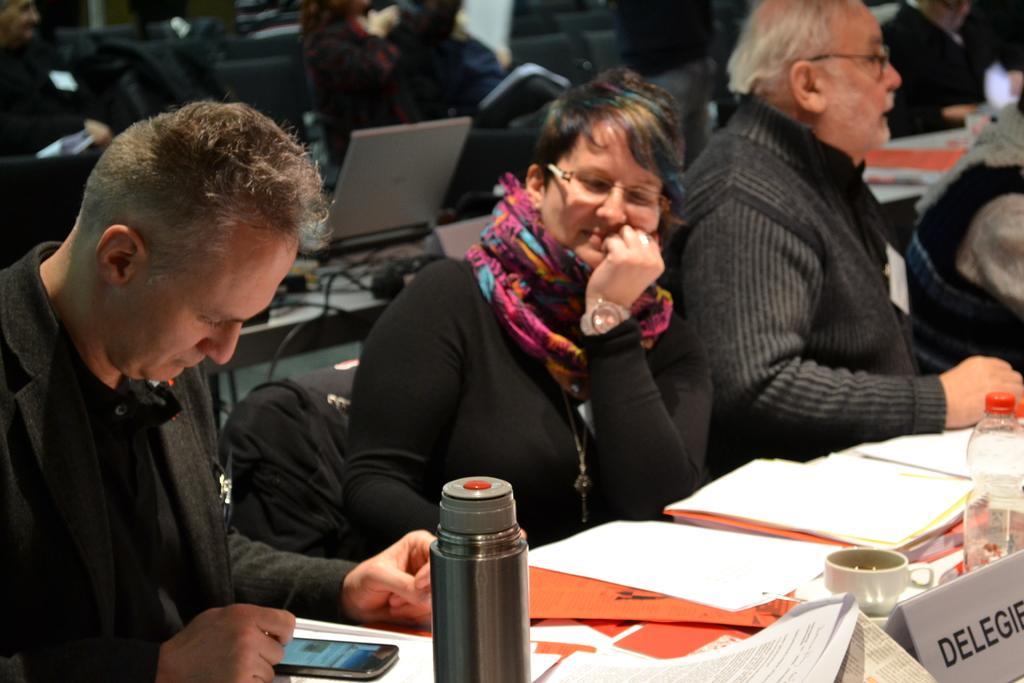Can you describe this image briefly? In this image there is a table, on that table there are bottles, books, cups and a mobile, behind the table there are people sitting on chairs, in the background there is another table, on that table there is a laptop and other objects, behind the table there are chairs on that chairs people are sitting and it is blurred. 